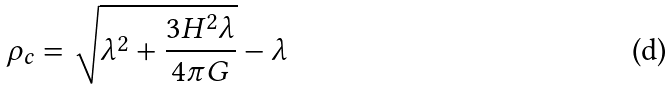Convert formula to latex. <formula><loc_0><loc_0><loc_500><loc_500>\rho _ { c } = \sqrt { \lambda ^ { 2 } + \frac { 3 H ^ { 2 } \lambda } { 4 \pi G } } - \lambda</formula> 